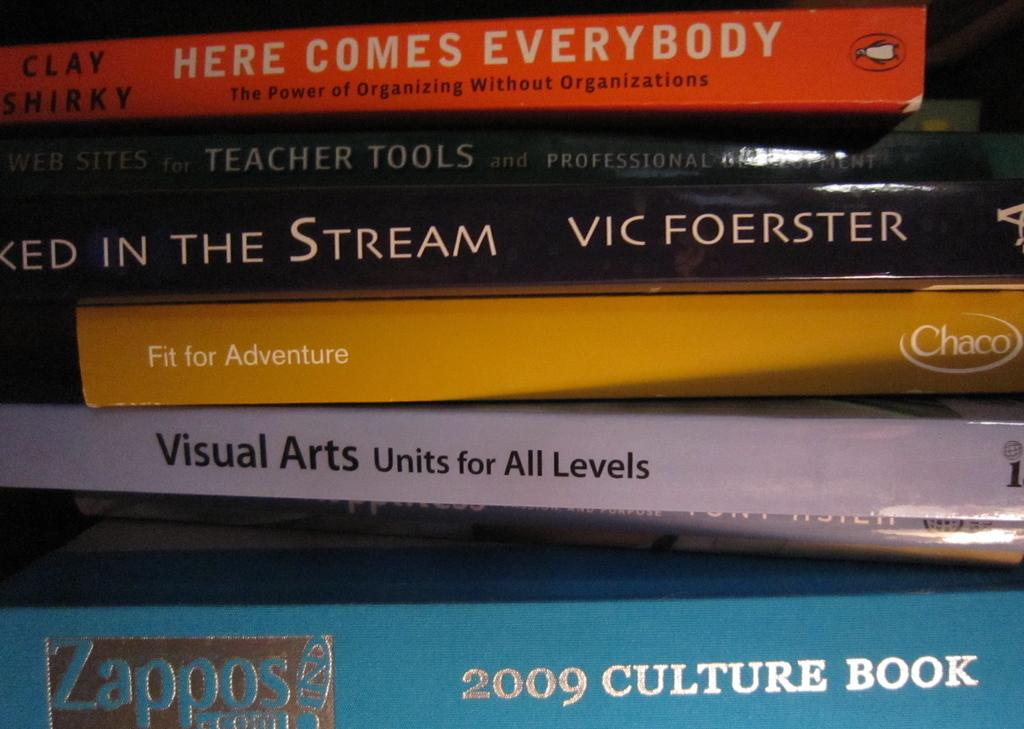<image>
Write a terse but informative summary of the picture. A book titled Visual Arts Units for All Levels is in a stack of books. 